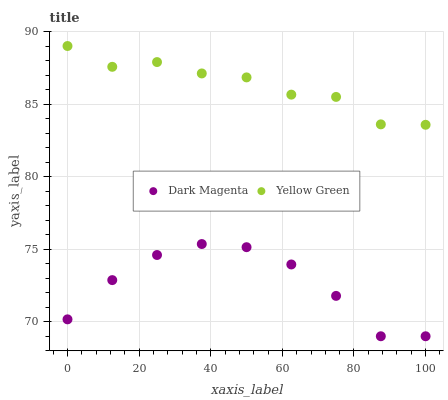Does Dark Magenta have the minimum area under the curve?
Answer yes or no. Yes. Does Yellow Green have the maximum area under the curve?
Answer yes or no. Yes. Does Yellow Green have the minimum area under the curve?
Answer yes or no. No. Is Dark Magenta the smoothest?
Answer yes or no. Yes. Is Yellow Green the roughest?
Answer yes or no. Yes. Is Yellow Green the smoothest?
Answer yes or no. No. Does Dark Magenta have the lowest value?
Answer yes or no. Yes. Does Yellow Green have the lowest value?
Answer yes or no. No. Does Yellow Green have the highest value?
Answer yes or no. Yes. Is Dark Magenta less than Yellow Green?
Answer yes or no. Yes. Is Yellow Green greater than Dark Magenta?
Answer yes or no. Yes. Does Dark Magenta intersect Yellow Green?
Answer yes or no. No. 